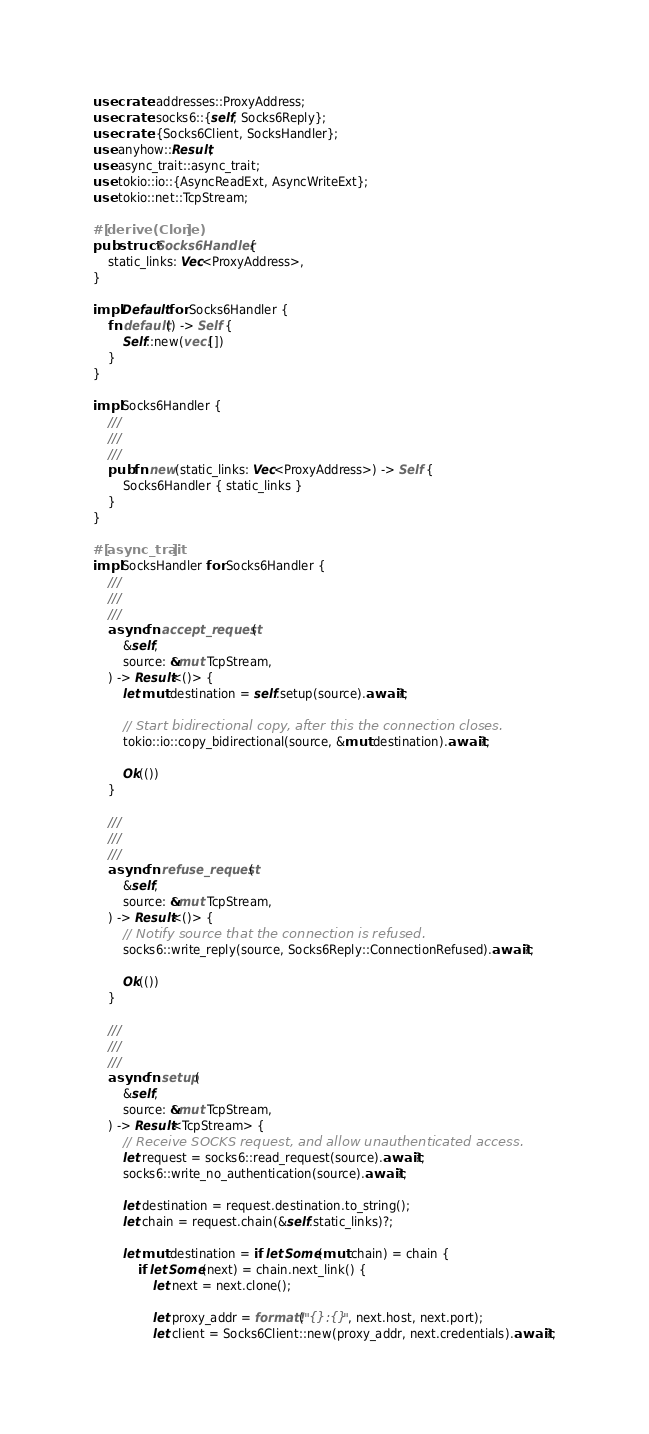<code> <loc_0><loc_0><loc_500><loc_500><_Rust_>use crate::addresses::ProxyAddress;
use crate::socks6::{self, Socks6Reply};
use crate::{Socks6Client, SocksHandler};
use anyhow::Result;
use async_trait::async_trait;
use tokio::io::{AsyncReadExt, AsyncWriteExt};
use tokio::net::TcpStream;

#[derive(Clone)]
pub struct Socks6Handler {
    static_links: Vec<ProxyAddress>,
}

impl Default for Socks6Handler {
    fn default() -> Self {
        Self::new(vec![])
    }
}

impl Socks6Handler {
    ///
    ///
    ///
    pub fn new(static_links: Vec<ProxyAddress>) -> Self {
        Socks6Handler { static_links }
    }
}

#[async_trait]
impl SocksHandler for Socks6Handler {
    ///
    ///
    ///
    async fn accept_request(
        &self,
        source: &mut TcpStream,
    ) -> Result<()> {
        let mut destination = self.setup(source).await?;

        // Start bidirectional copy, after this the connection closes.
        tokio::io::copy_bidirectional(source, &mut destination).await?;

        Ok(())
    }

    ///
    ///
    ///
    async fn refuse_request(
        &self,
        source: &mut TcpStream,
    ) -> Result<()> {
        // Notify source that the connection is refused.
        socks6::write_reply(source, Socks6Reply::ConnectionRefused).await?;

        Ok(())
    }

    ///
    ///
    ///
    async fn setup(
        &self,
        source: &mut TcpStream,
    ) -> Result<TcpStream> {
        // Receive SOCKS request, and allow unauthenticated access.
        let request = socks6::read_request(source).await?;
        socks6::write_no_authentication(source).await?;

        let destination = request.destination.to_string();
        let chain = request.chain(&self.static_links)?;

        let mut destination = if let Some(mut chain) = chain {
            if let Some(next) = chain.next_link() {
                let next = next.clone();

                let proxy_addr = format!("{}:{}", next.host, next.port);
                let client = Socks6Client::new(proxy_addr, next.credentials).await?;
</code> 